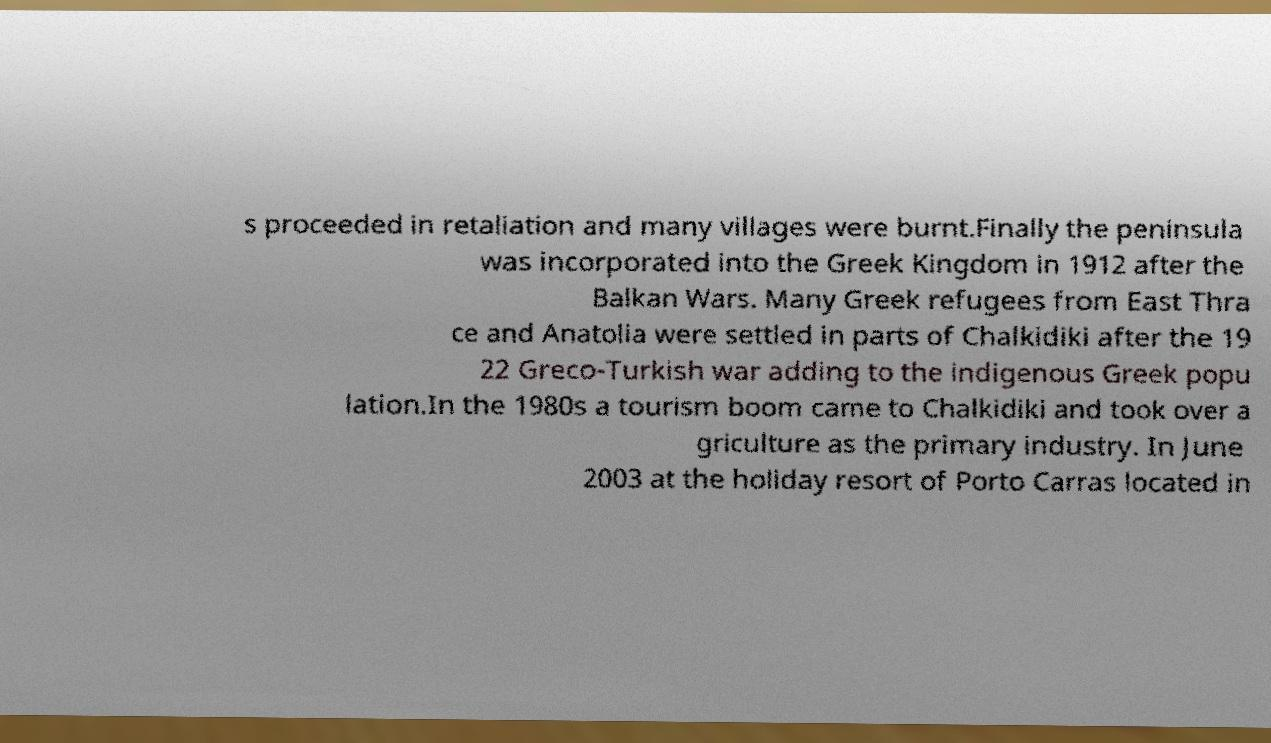What messages or text are displayed in this image? I need them in a readable, typed format. s proceeded in retaliation and many villages were burnt.Finally the peninsula was incorporated into the Greek Kingdom in 1912 after the Balkan Wars. Many Greek refugees from East Thra ce and Anatolia were settled in parts of Chalkidiki after the 19 22 Greco-Turkish war adding to the indigenous Greek popu lation.In the 1980s a tourism boom came to Chalkidiki and took over a griculture as the primary industry. In June 2003 at the holiday resort of Porto Carras located in 